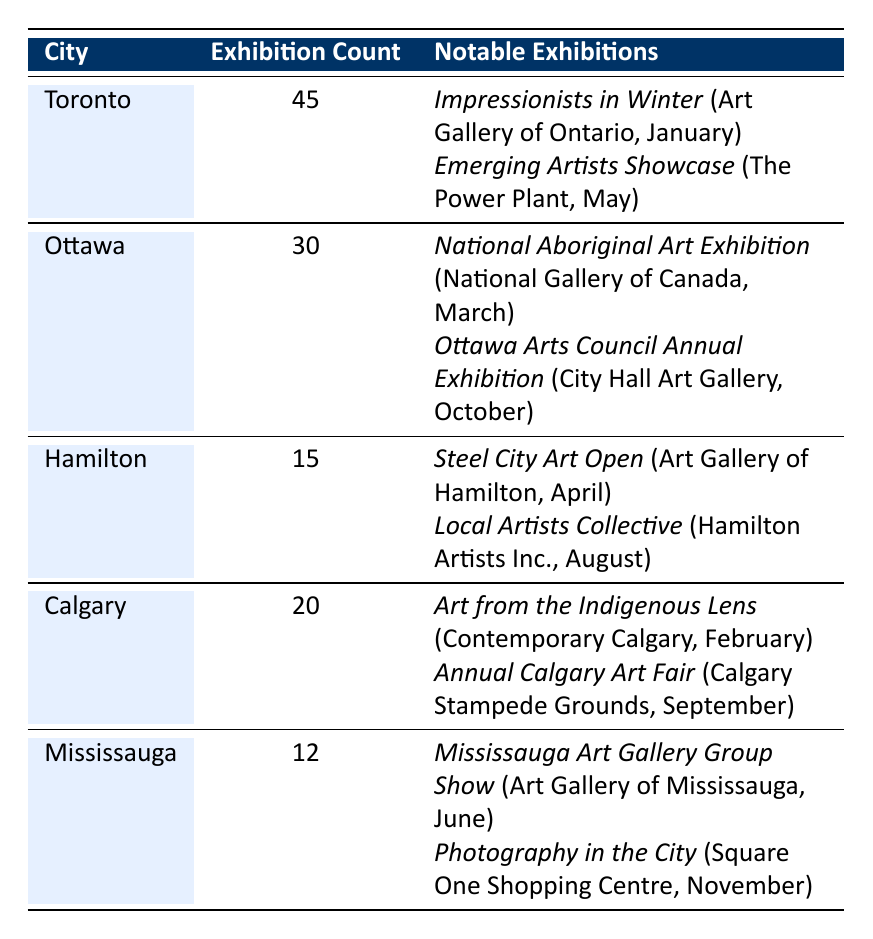What city had the highest number of art exhibitions? By observing the "Exhibition Count" column, Toronto shows the highest exhibition count at 45.
Answer: Toronto How many art exhibitions were held in Ottawa? The "Exhibition Count" for Ottawa is clearly stated as 30 in the table.
Answer: 30 Which notable exhibition occurred in February? Checking the notable exhibitions under Calgary, "Art from the Indigenous Lens" took place in February.
Answer: Art from the Indigenous Lens What is the total number of art exhibitions across all listed cities? Adding the exhibition counts: 45 (Toronto) + 30 (Ottawa) + 15 (Hamilton) + 20 (Calgary) + 12 (Mississauga) = 132.
Answer: 132 Did Hamilton host more exhibitions than Mississauga? Comparing the exhibition counts: Hamilton has 15 and Mississauga has 12; thus, Hamilton hosted more.
Answer: Yes What is the average number of exhibitions held in the cities listed? The total number of exhibitions is 132, and there are 5 cities. So, the average is 132/5 = 26.4.
Answer: 26.4 Which city had fewer exhibitions, Calgary or Hamilton? Calgary has 20 exhibitions while Hamilton has 15. Comparing these counts shows Hamilton had fewer exhibitions.
Answer: Hamilton How many notable exhibitions were listed for Mississauga? There are 2 notable exhibitions mentioned under Mississauga in the table.
Answer: 2 What was the month with the least number of notable exhibitions across all cities? By analyzing the months of the notable exhibitions, the months with one exhibition each (January, March, April, June, September, November) indicate that these months are tied for the least.
Answer: January, March, April, June, September, November What was the total number of exhibitions in Toronto and Ottawa combined? The sum of Toronto's 45 exhibitions and Ottawa's 30 exhibitions is 45 + 30 = 75.
Answer: 75 Is the "Emerging Artists Showcase" the only notable exhibition in May? In the table, it is the only notable exhibition listed for May in Toronto.
Answer: Yes 